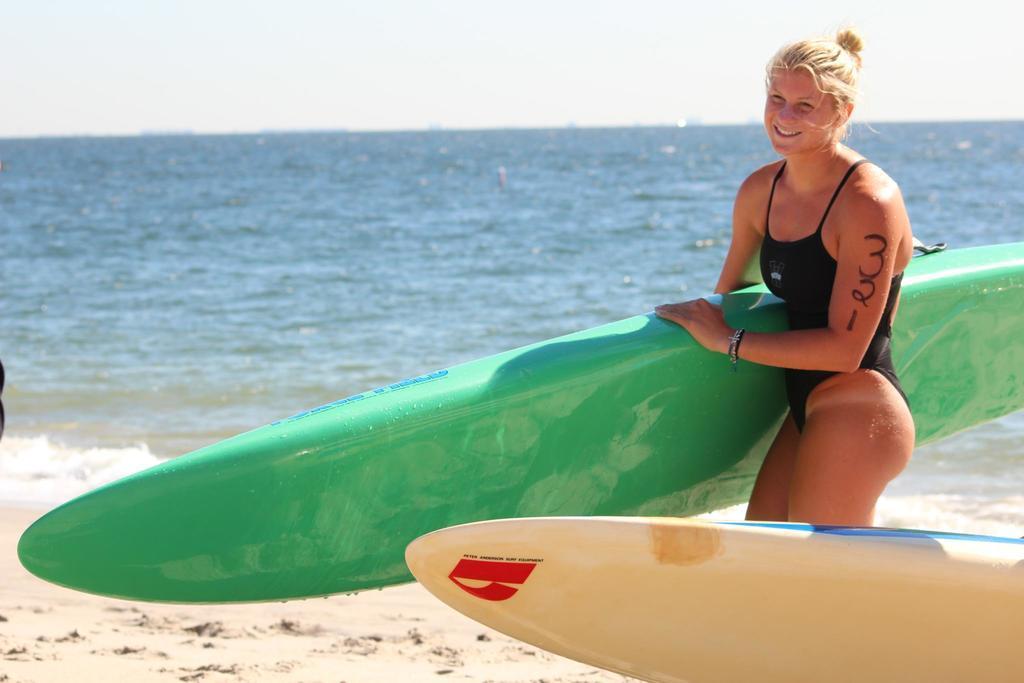Describe this image in one or two sentences. On the background of the picture we can see sky. This is a sea. This is sand. Here we can see one women wearing a swimsuit and she is holding a pretty smile on her face. We can see surfboard in her hands. 